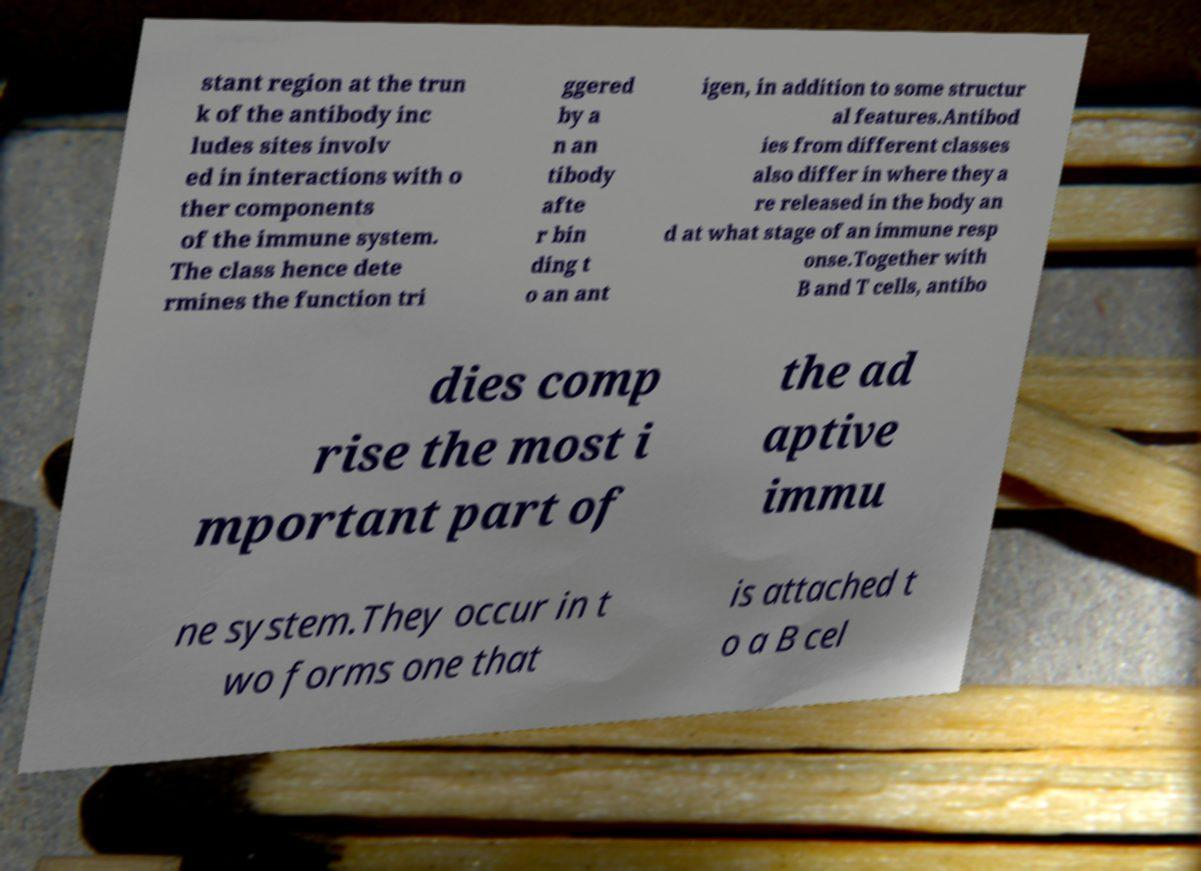Please identify and transcribe the text found in this image. stant region at the trun k of the antibody inc ludes sites involv ed in interactions with o ther components of the immune system. The class hence dete rmines the function tri ggered by a n an tibody afte r bin ding t o an ant igen, in addition to some structur al features.Antibod ies from different classes also differ in where they a re released in the body an d at what stage of an immune resp onse.Together with B and T cells, antibo dies comp rise the most i mportant part of the ad aptive immu ne system.They occur in t wo forms one that is attached t o a B cel 